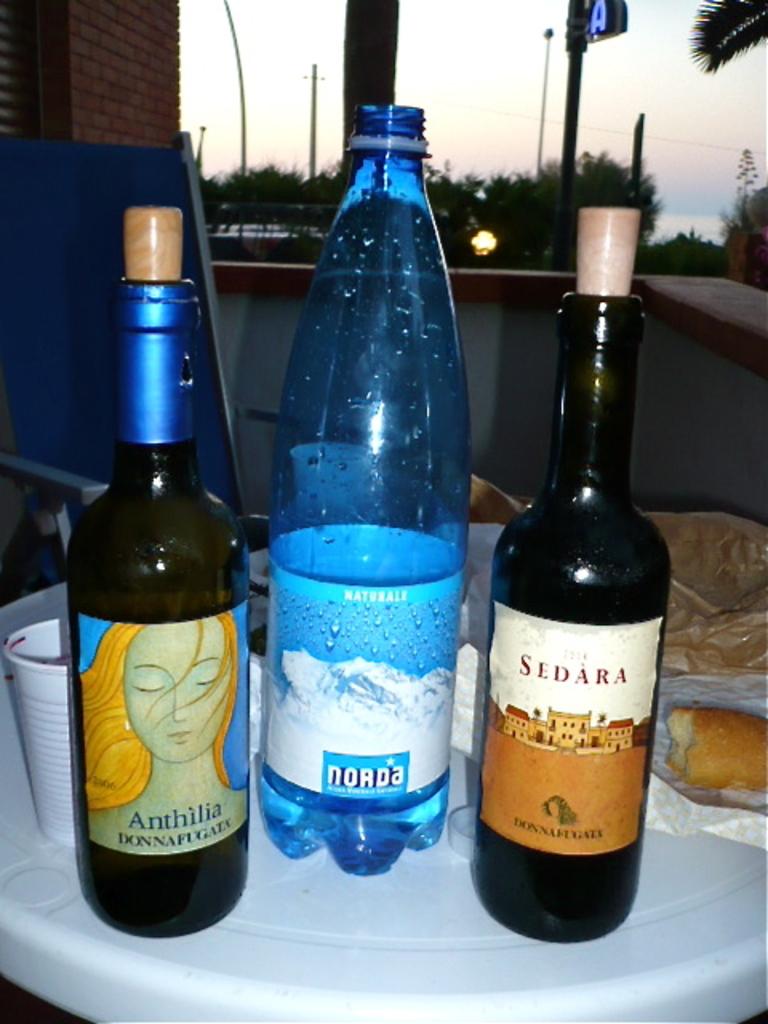What is the brand on the blue bottle?
Provide a succinct answer. Norda. 